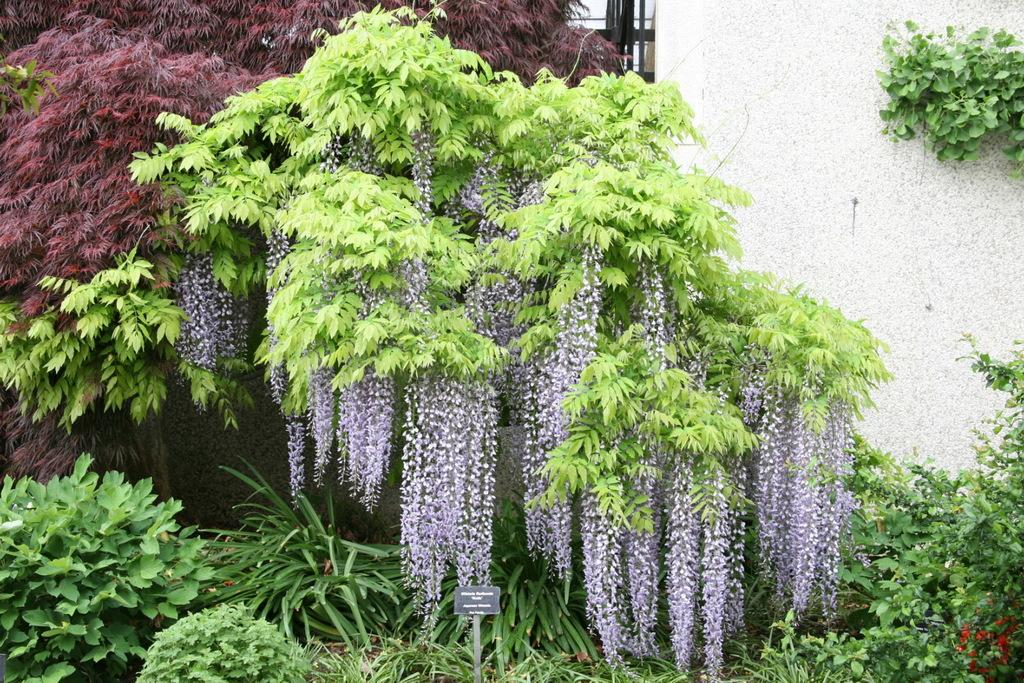What type of vegetation can be seen in the image? There are plants, trees, and flowers in the image. What structure is present in the image? There is a name board in the image. What type of architectural feature is visible in the image? There is a wall in the image. Can you describe the background of the image? In the center of the background, there appears to be a gate and a wall. What is the tax rate for the land depicted in the image? There is no information about tax rates or land in the image; it primarily features vegetation and a name board. 